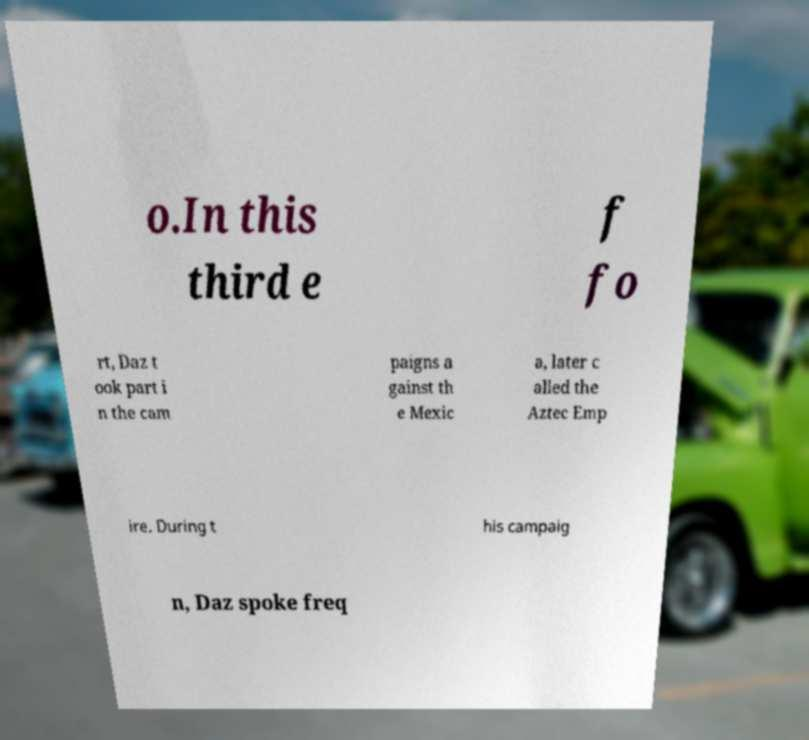Could you extract and type out the text from this image? o.In this third e f fo rt, Daz t ook part i n the cam paigns a gainst th e Mexic a, later c alled the Aztec Emp ire. During t his campaig n, Daz spoke freq 